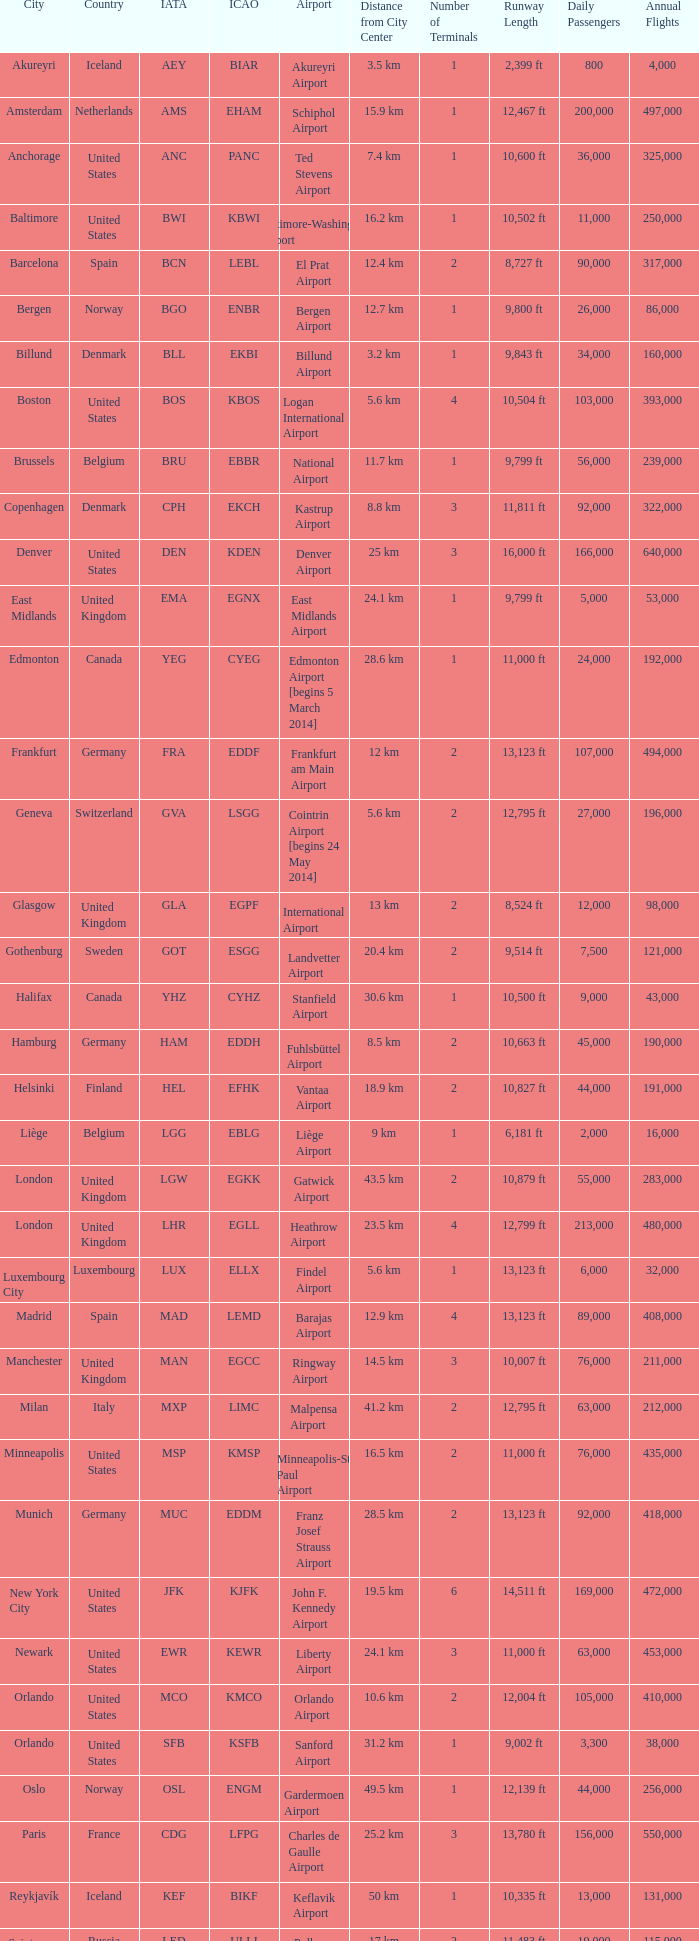What airport can be recognized by the icao identifier eddh? Fuhlsbüttel Airport. 